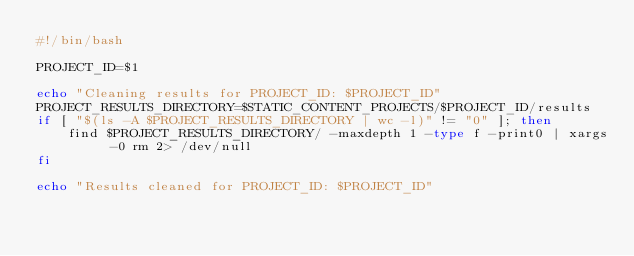<code> <loc_0><loc_0><loc_500><loc_500><_Bash_>#!/bin/bash

PROJECT_ID=$1

echo "Cleaning results for PROJECT_ID: $PROJECT_ID"
PROJECT_RESULTS_DIRECTORY=$STATIC_CONTENT_PROJECTS/$PROJECT_ID/results
if [ "$(ls -A $PROJECT_RESULTS_DIRECTORY | wc -l)" != "0" ]; then
    find $PROJECT_RESULTS_DIRECTORY/ -maxdepth 1 -type f -print0 | xargs -0 rm 2> /dev/null
fi

echo "Results cleaned for PROJECT_ID: $PROJECT_ID"
</code> 